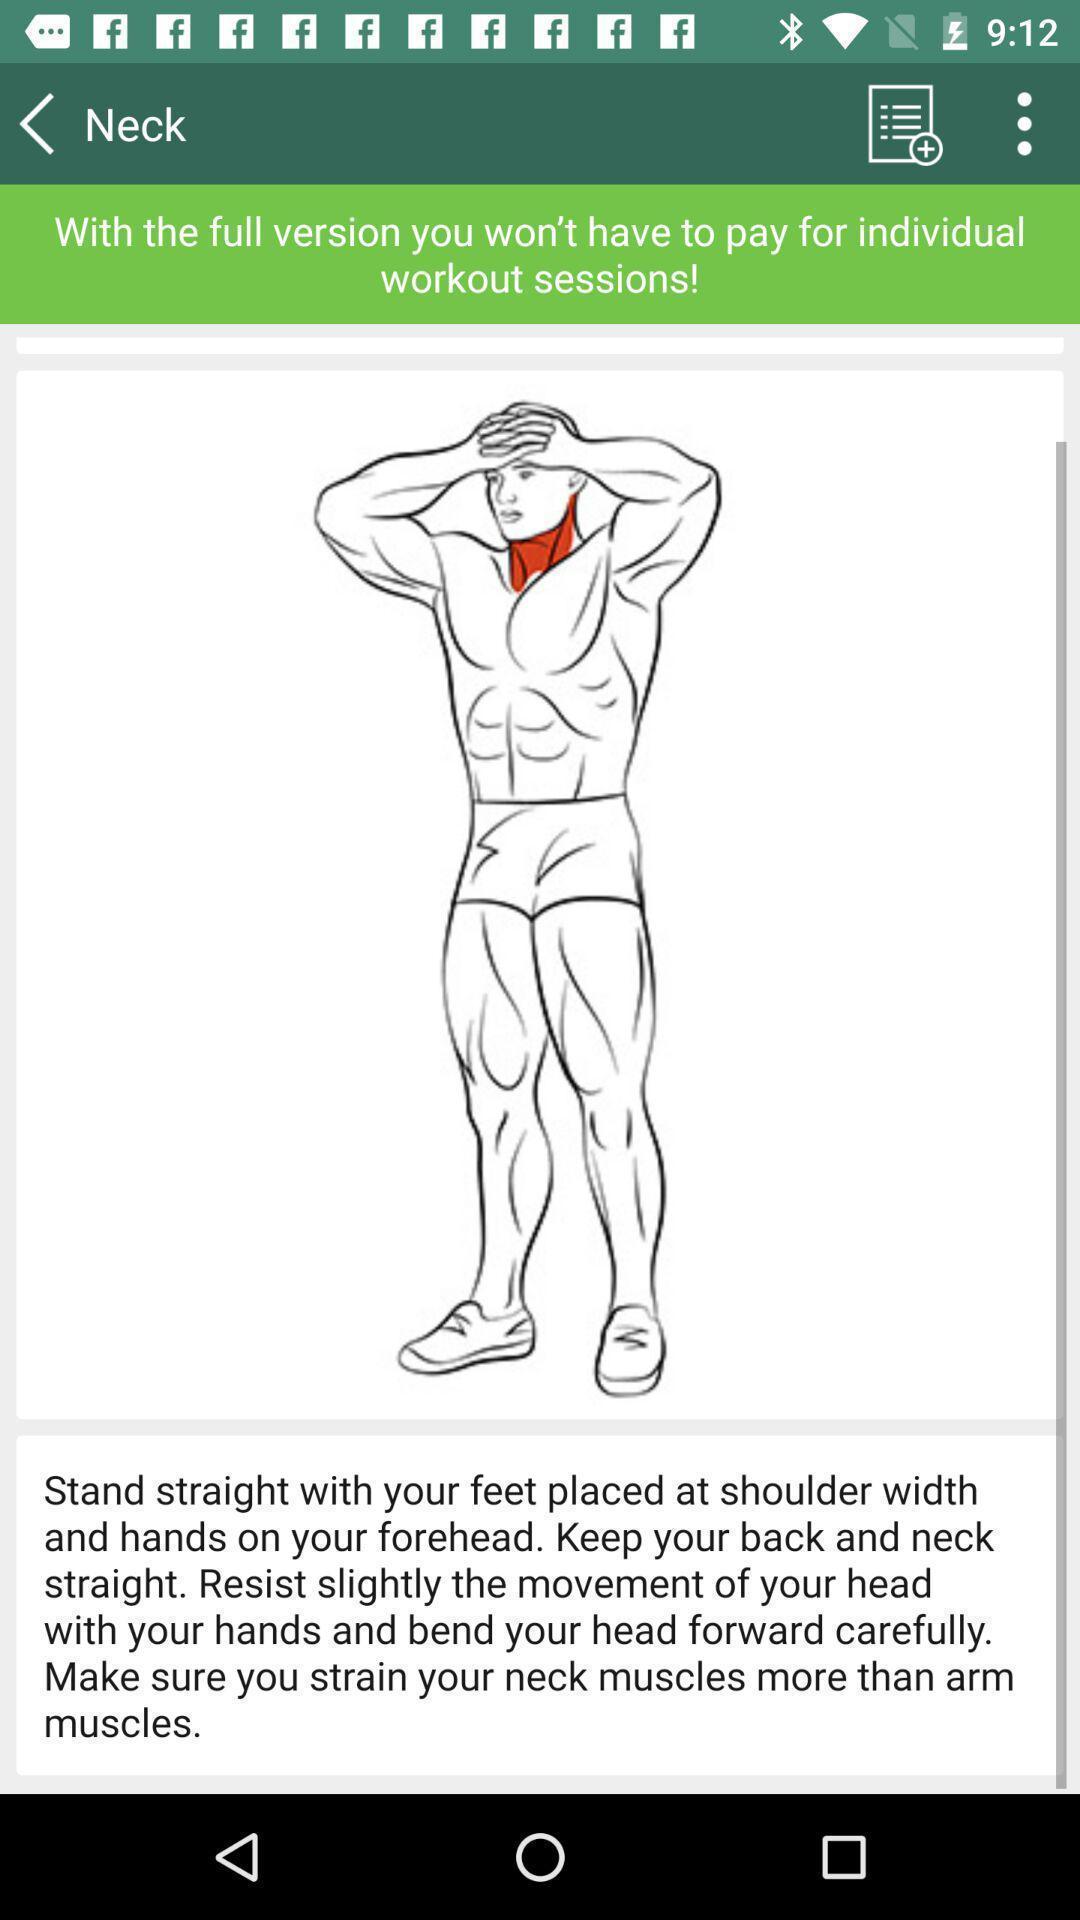Give me a summary of this screen capture. Page of exercise session in the fitness app. 